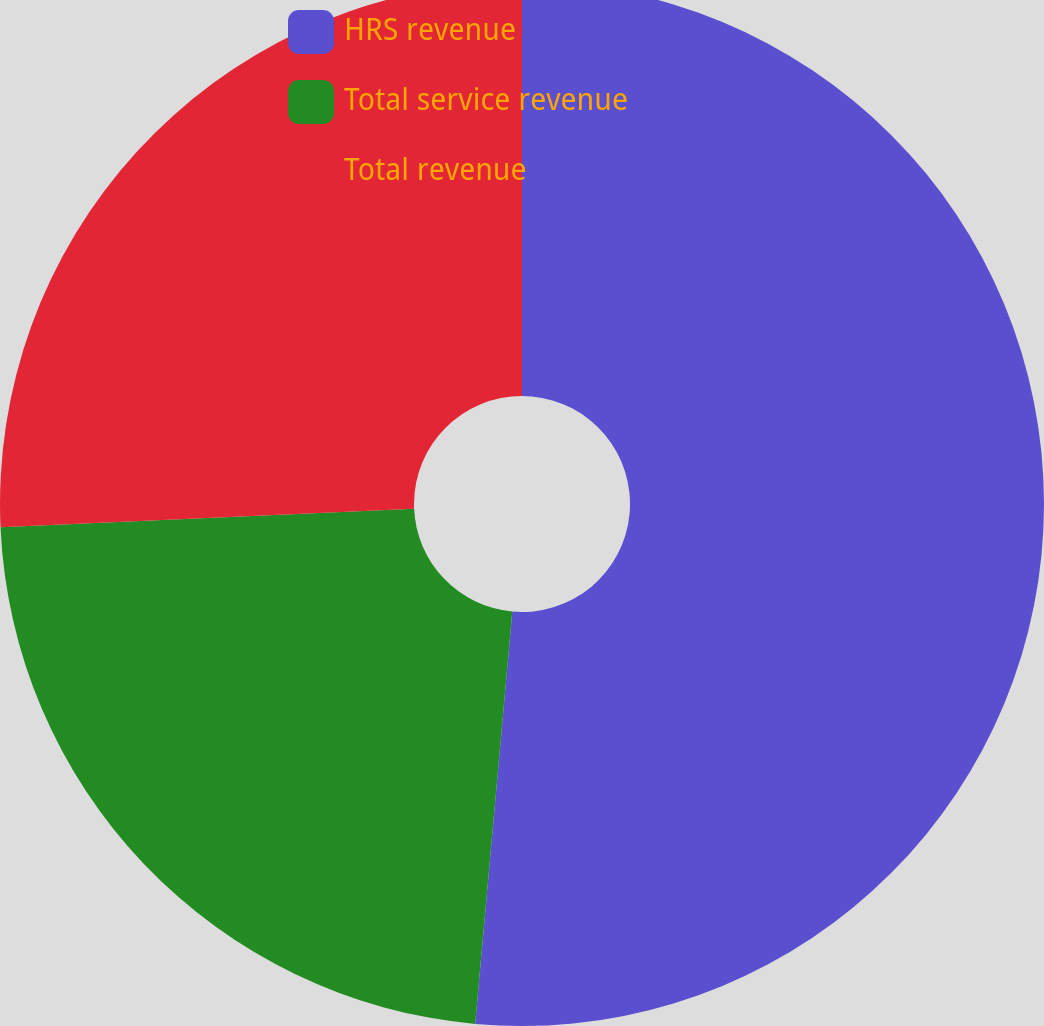Convert chart to OTSL. <chart><loc_0><loc_0><loc_500><loc_500><pie_chart><fcel>HRS revenue<fcel>Total service revenue<fcel>Total revenue<nl><fcel>51.43%<fcel>22.86%<fcel>25.71%<nl></chart> 